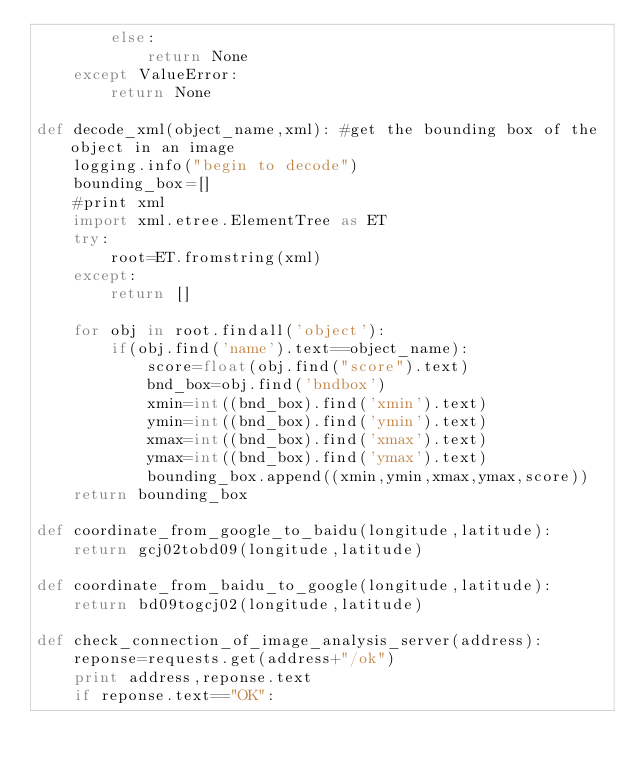<code> <loc_0><loc_0><loc_500><loc_500><_Python_>        else:
            return None
    except ValueError:
        return None
       
def decode_xml(object_name,xml): #get the bounding box of the object in an image
    logging.info("begin to decode")
    bounding_box=[]
    #print xml
    import xml.etree.ElementTree as ET
    try:
        root=ET.fromstring(xml)
    except:
        return []

    for obj in root.findall('object'):
        if(obj.find('name').text==object_name):
            score=float(obj.find("score").text)
            bnd_box=obj.find('bndbox')
            xmin=int((bnd_box).find('xmin').text)
            ymin=int((bnd_box).find('ymin').text)
            xmax=int((bnd_box).find('xmax').text)
            ymax=int((bnd_box).find('ymax').text)
            bounding_box.append((xmin,ymin,xmax,ymax,score))
    return bounding_box

def coordinate_from_google_to_baidu(longitude,latitude): 
    return gcj02tobd09(longitude,latitude)

def coordinate_from_baidu_to_google(longitude,latitude):
    return bd09togcj02(longitude,latitude)

def check_connection_of_image_analysis_server(address):
    reponse=requests.get(address+"/ok")
    print address,reponse.text
    if reponse.text=="OK":</code> 